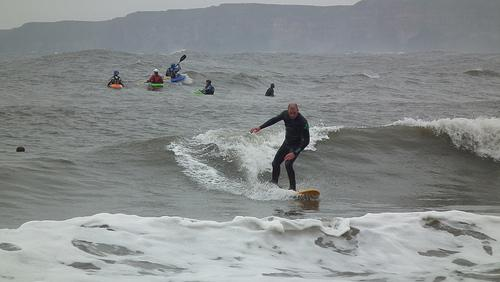Mention the types of water sports that are taking place in the image. Several water sports are happening, including surfing, kayaking, and swimming in the ocean. Use five words to describe the scenery and action captured in the image. Ocean, water sports, surfing, kayaking, landscape. Briefly describe the main action taking place in the image and the setting. In the image, people are enjoying water sports like kayaking and surfing in the ocean, with mountains in the background. Narrate the scene featuring people doing water sports, highlighting the equipment they are using. A group of people are surfing and kayaking on different colored surfboards and kayaks, using paddles and wearing various gear in the ocean. Describe the people in the image and their various activities. The image has people swimming, surfing, and paddling kayaks, some are wearing wetsuits, helmets or swimwear, and all are enjoying the ocean. In one sentence, describe the scene in the image and the participants. The image shows a group of people engaging in various water sports, such as surfing and kayaking, in the ocean with mountains in the background. In the image, mention the various watercraft, equipment or items involved. The image features surfboards, kayaks, paddles, and people wearing wetsuits and helmets. Mention the most prominent activity being performed by the individuals in the image. People are engaging in various water sports, such as surfing, kayaking, and swimming in the ocean. Describe the scene taking place in this image and the people involved. This image captures a group of people doing different water activities like surfing, kayaking, and swimming, with a mountain landscape in the background. Identify the type of environment and the main activities happening in the image. The image depicts an ocean environment with people participating in water sports, including surfing and kayaking. Do you notice the orange color of the mountains? The mountains in the image have not been described with any color, let alone orange. Marvel at the large iceberg floating in the ocean. There is no iceberg in the image; the focus is on kayaking, surfing, and other water activities in the ocean. Can you see the yellow flowers in the image? There are no flowers in the image, but there are yellow elements such as a yellow surfboard. How gorgeous is the turquoise sea in the image! The color of the sea is gray, not turquoise. The man standing on the shore appears to be wearing a dark green wetsuit. The man in the image is actually wearing a black wetsuit, not dark green. Isn't it fascinating how a woman surfs skillfully on the water? The surfer in the image is a man, not a woman. There is one kid standing on the surfboard, right? The person on the surfboard is a man, not a kid. Look at the beautiful sunset in the background. The image does not describe a sunset, but rather focuses on the ocean and the activities of the people. Is it true that the kayakers are near a sandy beach? The image contains no mention of a sandy beach, only the ocean and its surroundings. The water in the image seems shallow for swimming, isn't it? The water appears to be deep enough for kayaking and surfing, so it cannot be considered shallow for swimming. 